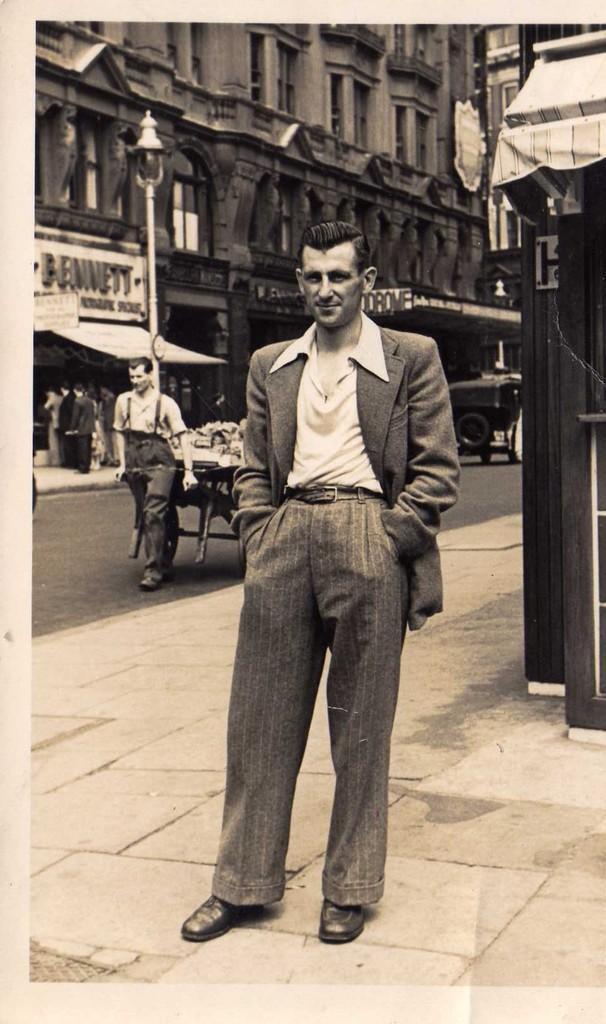How would you summarize this image in a sentence or two? This is a black and white image. There are a few people, building, a pole and a vehicle. We can see the ground. We can see a board with some text. We can also see the shed and a trolley with some objects. 